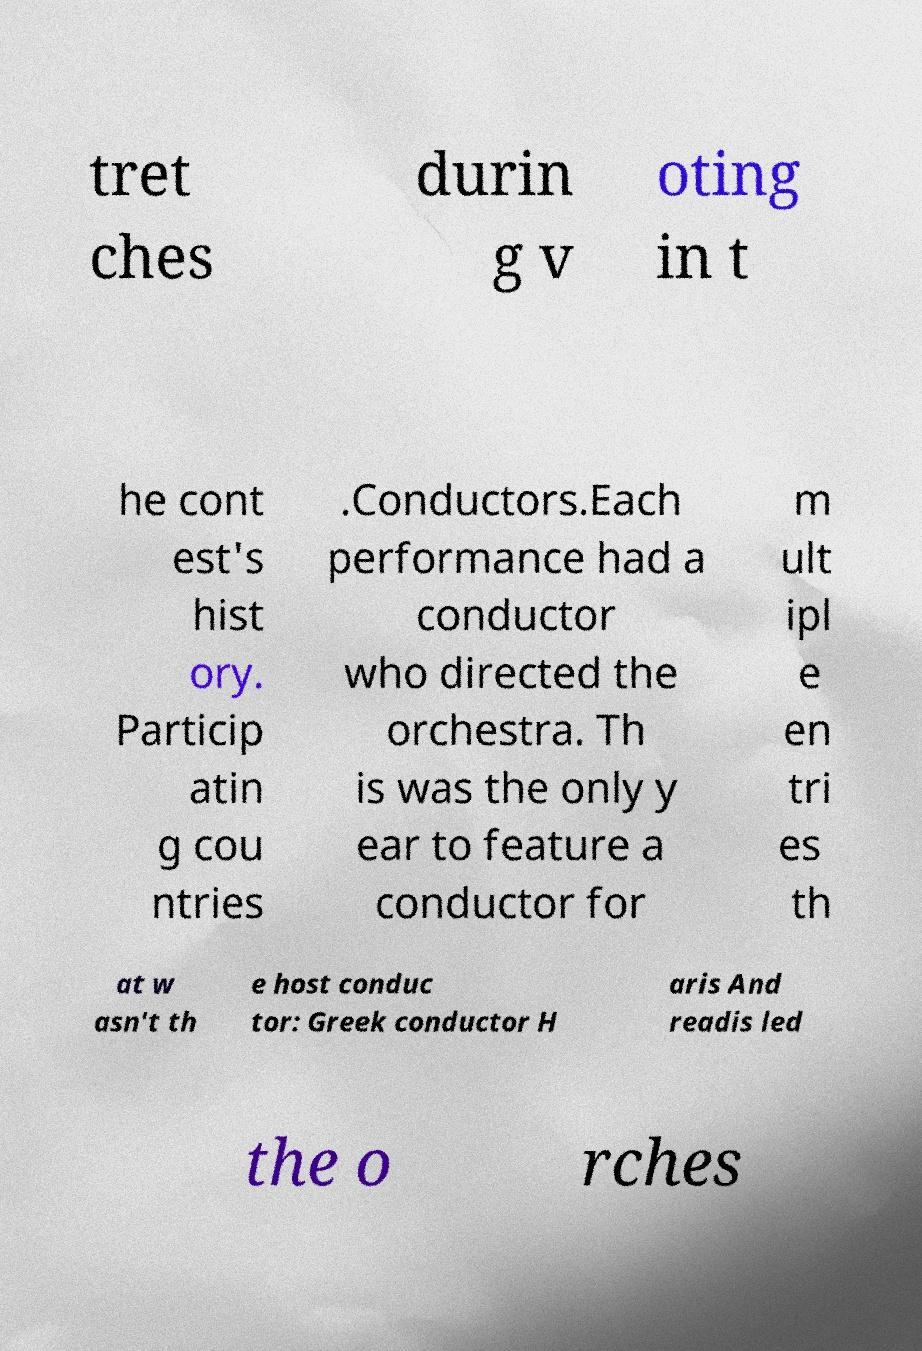What messages or text are displayed in this image? I need them in a readable, typed format. tret ches durin g v oting in t he cont est's hist ory. Particip atin g cou ntries .Conductors.Each performance had a conductor who directed the orchestra. Th is was the only y ear to feature a conductor for m ult ipl e en tri es th at w asn't th e host conduc tor: Greek conductor H aris And readis led the o rches 